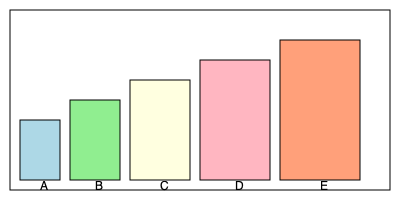A nephrologist has prescribed five different medications for a patient with chronic kidney disease. As the pharmacist, you need to arrange the pill bottles on a shelf in order of increasing size. Given the image above, what is the correct order of the bottles from smallest to largest? To arrange the pill bottles in order of increasing size, we need to compare their heights and widths:

1. Bottle A: 60 units tall, 40 units wide
2. Bottle B: 80 units tall, 50 units wide
3. Bottle C: 100 units tall, 60 units wide
4. Bottle D: 120 units tall, 70 units wide
5. Bottle E: 140 units tall, 80 units wide

Comparing these dimensions, we can see that:

- A is smaller than B in both height and width
- B is smaller than C in both height and width
- C is smaller than D in both height and width
- D is smaller than E in both height and width

Therefore, the correct order from smallest to largest is: A, B, C, D, E.
Answer: A, B, C, D, E 